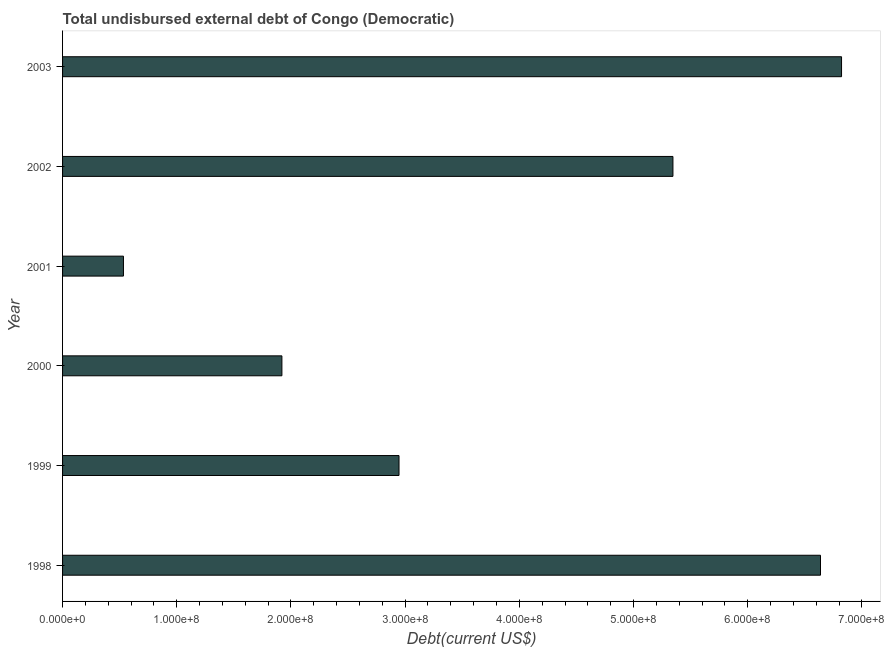Does the graph contain any zero values?
Provide a short and direct response. No. Does the graph contain grids?
Offer a terse response. No. What is the title of the graph?
Provide a short and direct response. Total undisbursed external debt of Congo (Democratic). What is the label or title of the X-axis?
Give a very brief answer. Debt(current US$). What is the total debt in 2000?
Make the answer very short. 1.92e+08. Across all years, what is the maximum total debt?
Offer a terse response. 6.82e+08. Across all years, what is the minimum total debt?
Offer a very short reply. 5.33e+07. What is the sum of the total debt?
Keep it short and to the point. 2.42e+09. What is the difference between the total debt in 2001 and 2002?
Your answer should be very brief. -4.81e+08. What is the average total debt per year?
Provide a short and direct response. 4.03e+08. What is the median total debt?
Ensure brevity in your answer.  4.15e+08. In how many years, is the total debt greater than 660000000 US$?
Offer a very short reply. 2. Do a majority of the years between 2003 and 2000 (inclusive) have total debt greater than 440000000 US$?
Provide a succinct answer. Yes. What is the ratio of the total debt in 1998 to that in 2001?
Make the answer very short. 12.45. What is the difference between the highest and the second highest total debt?
Give a very brief answer. 1.84e+07. What is the difference between the highest and the lowest total debt?
Offer a terse response. 6.29e+08. Are all the bars in the graph horizontal?
Give a very brief answer. Yes. What is the difference between two consecutive major ticks on the X-axis?
Ensure brevity in your answer.  1.00e+08. Are the values on the major ticks of X-axis written in scientific E-notation?
Provide a short and direct response. Yes. What is the Debt(current US$) of 1998?
Ensure brevity in your answer.  6.64e+08. What is the Debt(current US$) in 1999?
Your answer should be very brief. 2.95e+08. What is the Debt(current US$) in 2000?
Provide a succinct answer. 1.92e+08. What is the Debt(current US$) in 2001?
Provide a short and direct response. 5.33e+07. What is the Debt(current US$) in 2002?
Keep it short and to the point. 5.35e+08. What is the Debt(current US$) of 2003?
Your answer should be compact. 6.82e+08. What is the difference between the Debt(current US$) in 1998 and 1999?
Provide a short and direct response. 3.69e+08. What is the difference between the Debt(current US$) in 1998 and 2000?
Ensure brevity in your answer.  4.72e+08. What is the difference between the Debt(current US$) in 1998 and 2001?
Offer a very short reply. 6.10e+08. What is the difference between the Debt(current US$) in 1998 and 2002?
Offer a very short reply. 1.29e+08. What is the difference between the Debt(current US$) in 1998 and 2003?
Make the answer very short. -1.84e+07. What is the difference between the Debt(current US$) in 1999 and 2000?
Your answer should be very brief. 1.03e+08. What is the difference between the Debt(current US$) in 1999 and 2001?
Ensure brevity in your answer.  2.41e+08. What is the difference between the Debt(current US$) in 1999 and 2002?
Ensure brevity in your answer.  -2.40e+08. What is the difference between the Debt(current US$) in 1999 and 2003?
Provide a short and direct response. -3.88e+08. What is the difference between the Debt(current US$) in 2000 and 2001?
Keep it short and to the point. 1.39e+08. What is the difference between the Debt(current US$) in 2000 and 2002?
Give a very brief answer. -3.42e+08. What is the difference between the Debt(current US$) in 2000 and 2003?
Provide a succinct answer. -4.90e+08. What is the difference between the Debt(current US$) in 2001 and 2002?
Offer a very short reply. -4.81e+08. What is the difference between the Debt(current US$) in 2001 and 2003?
Offer a terse response. -6.29e+08. What is the difference between the Debt(current US$) in 2002 and 2003?
Ensure brevity in your answer.  -1.48e+08. What is the ratio of the Debt(current US$) in 1998 to that in 1999?
Ensure brevity in your answer.  2.25. What is the ratio of the Debt(current US$) in 1998 to that in 2000?
Provide a succinct answer. 3.46. What is the ratio of the Debt(current US$) in 1998 to that in 2001?
Your answer should be very brief. 12.45. What is the ratio of the Debt(current US$) in 1998 to that in 2002?
Your answer should be very brief. 1.24. What is the ratio of the Debt(current US$) in 1998 to that in 2003?
Provide a short and direct response. 0.97. What is the ratio of the Debt(current US$) in 1999 to that in 2000?
Offer a very short reply. 1.53. What is the ratio of the Debt(current US$) in 1999 to that in 2001?
Your response must be concise. 5.53. What is the ratio of the Debt(current US$) in 1999 to that in 2002?
Offer a terse response. 0.55. What is the ratio of the Debt(current US$) in 1999 to that in 2003?
Make the answer very short. 0.43. What is the ratio of the Debt(current US$) in 2000 to that in 2001?
Give a very brief answer. 3.6. What is the ratio of the Debt(current US$) in 2000 to that in 2002?
Offer a terse response. 0.36. What is the ratio of the Debt(current US$) in 2000 to that in 2003?
Make the answer very short. 0.28. What is the ratio of the Debt(current US$) in 2001 to that in 2003?
Provide a succinct answer. 0.08. What is the ratio of the Debt(current US$) in 2002 to that in 2003?
Provide a succinct answer. 0.78. 